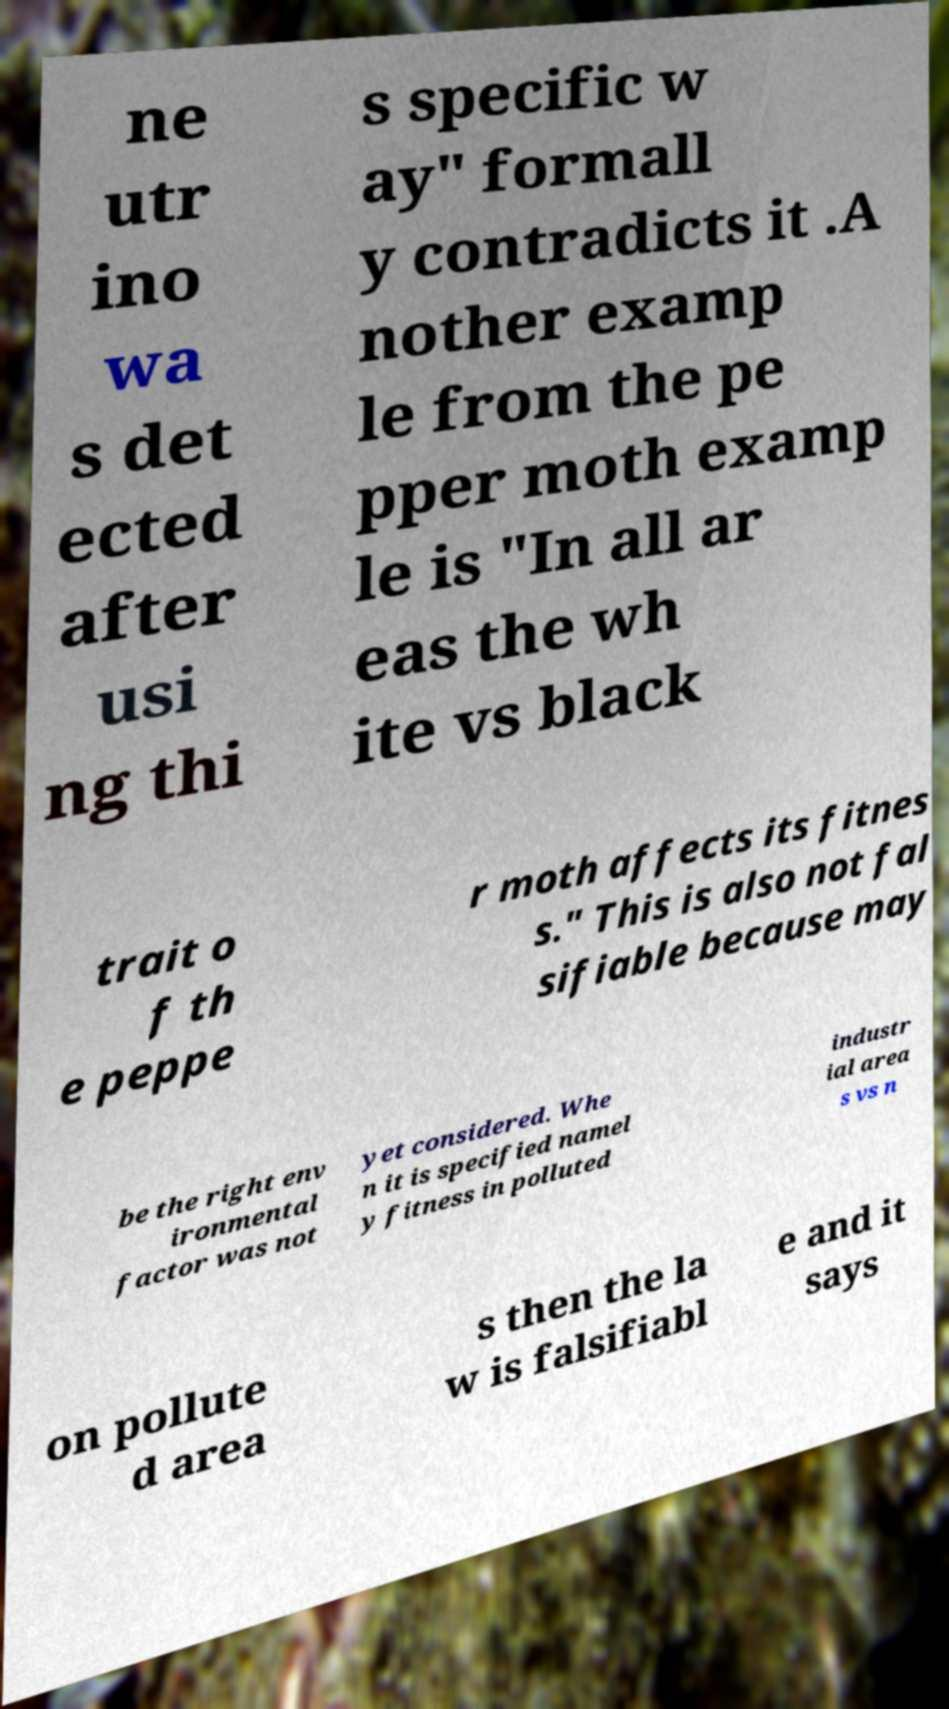Can you accurately transcribe the text from the provided image for me? ne utr ino wa s det ected after usi ng thi s specific w ay" formall y contradicts it .A nother examp le from the pe pper moth examp le is "In all ar eas the wh ite vs black trait o f th e peppe r moth affects its fitnes s." This is also not fal sifiable because may be the right env ironmental factor was not yet considered. Whe n it is specified namel y fitness in polluted industr ial area s vs n on pollute d area s then the la w is falsifiabl e and it says 